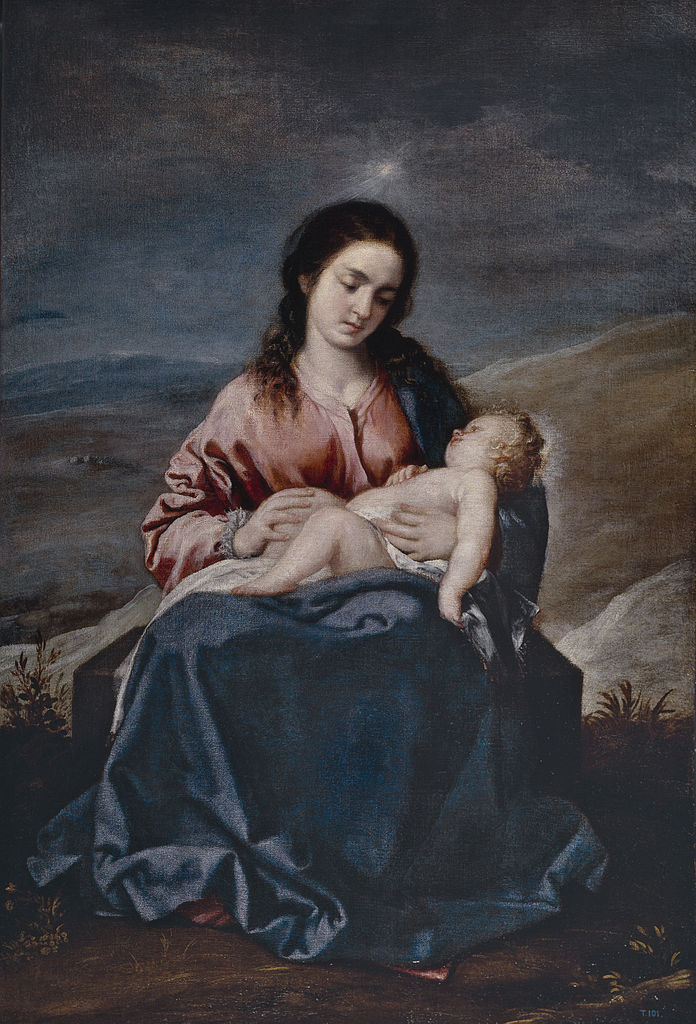What do you think is going on in this snapshot? The image illustrates a serene moment between a young woman and a baby. The woman, draped in softly flowing garments of pink and blue, tenderly cradles the child wrapped in a blue blanket. She sits calmly on a rock, her gaze focused on the baby, exuding a sense of quiet reverence and care. The dark sky and landscape in the background create a dramatic contrast to the warm, illuminated figures, suggesting that the scene is set during an early morning or late evening. The intricate use of color and light points to the Baroque style, characterized by vivid contrasts and detailed realism. This style, combined with the subject matter, suggests that the painting is a religious work, likely depicting the Virgin Mary and baby Jesus, reflecting themes of devotion and sanctity. The artist's mastery is evident in the depth and lifelike quality of the figures, as well as in the emotive narrative captured within the painting. 